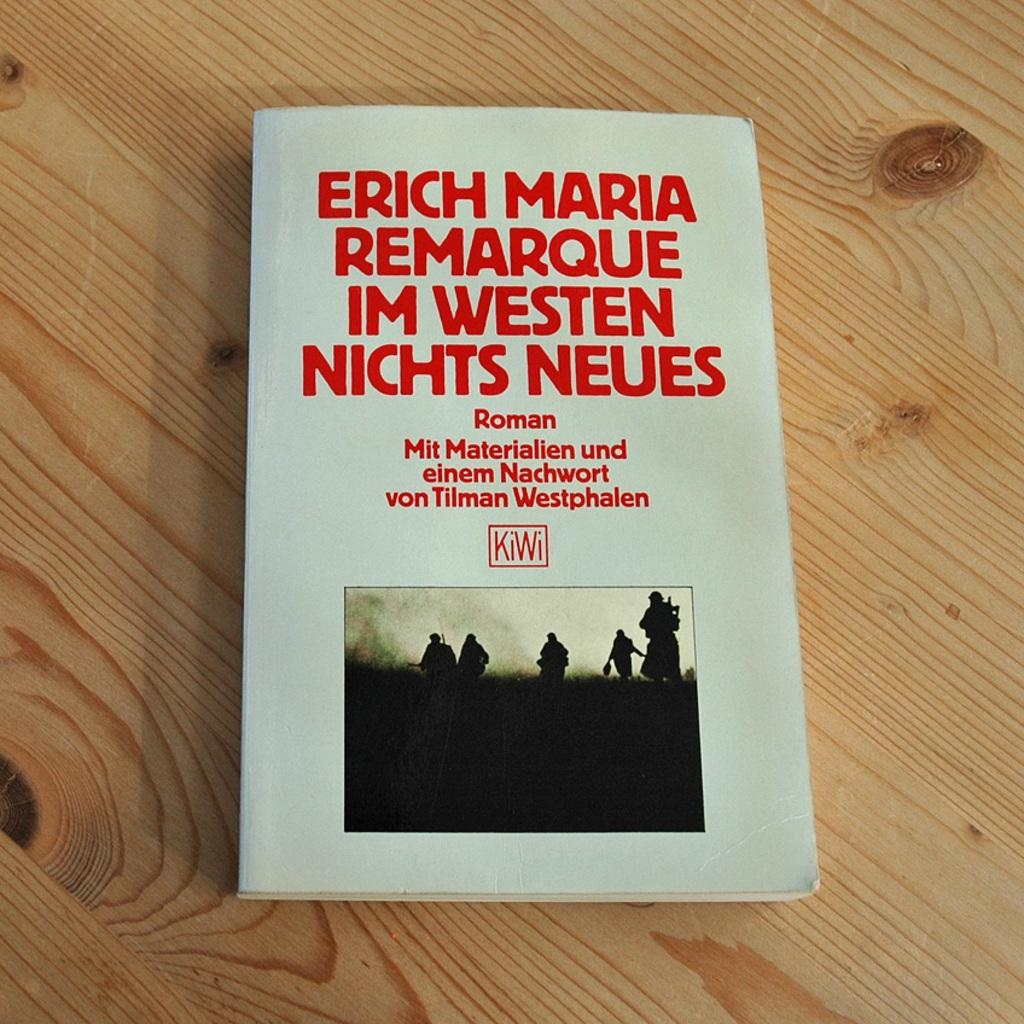<image>
Present a compact description of the photo's key features. A book cover shows several people and the word kiwi in a red box. 